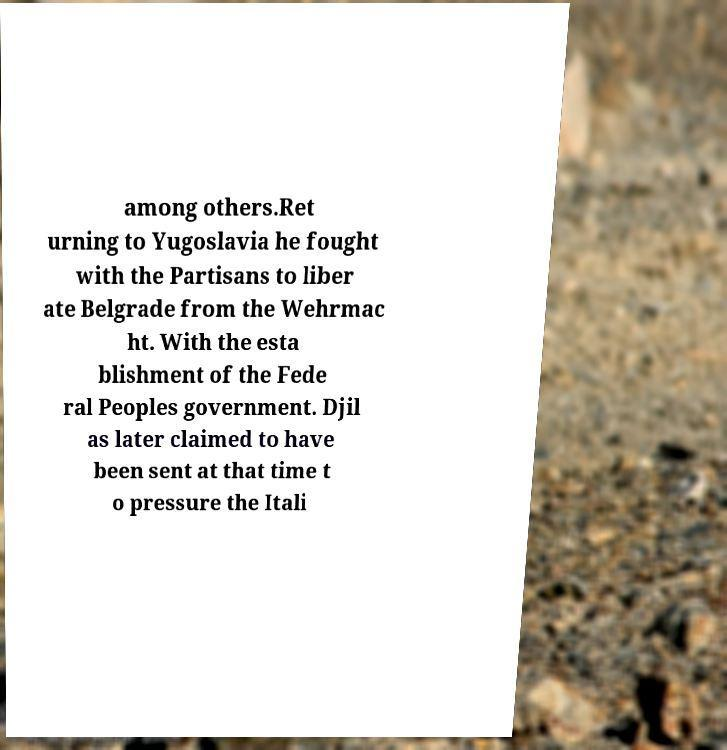What messages or text are displayed in this image? I need them in a readable, typed format. among others.Ret urning to Yugoslavia he fought with the Partisans to liber ate Belgrade from the Wehrmac ht. With the esta blishment of the Fede ral Peoples government. Djil as later claimed to have been sent at that time t o pressure the Itali 